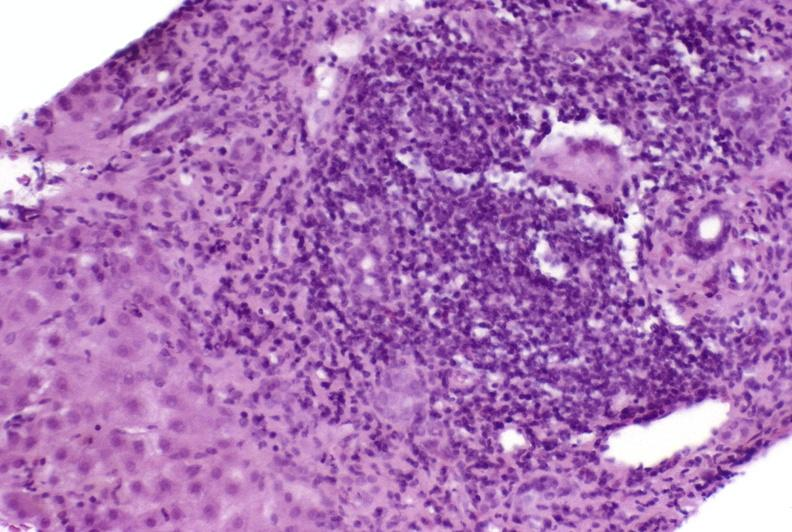s adrenal of premature 30 week gestation gram infant lesion present?
Answer the question using a single word or phrase. No 